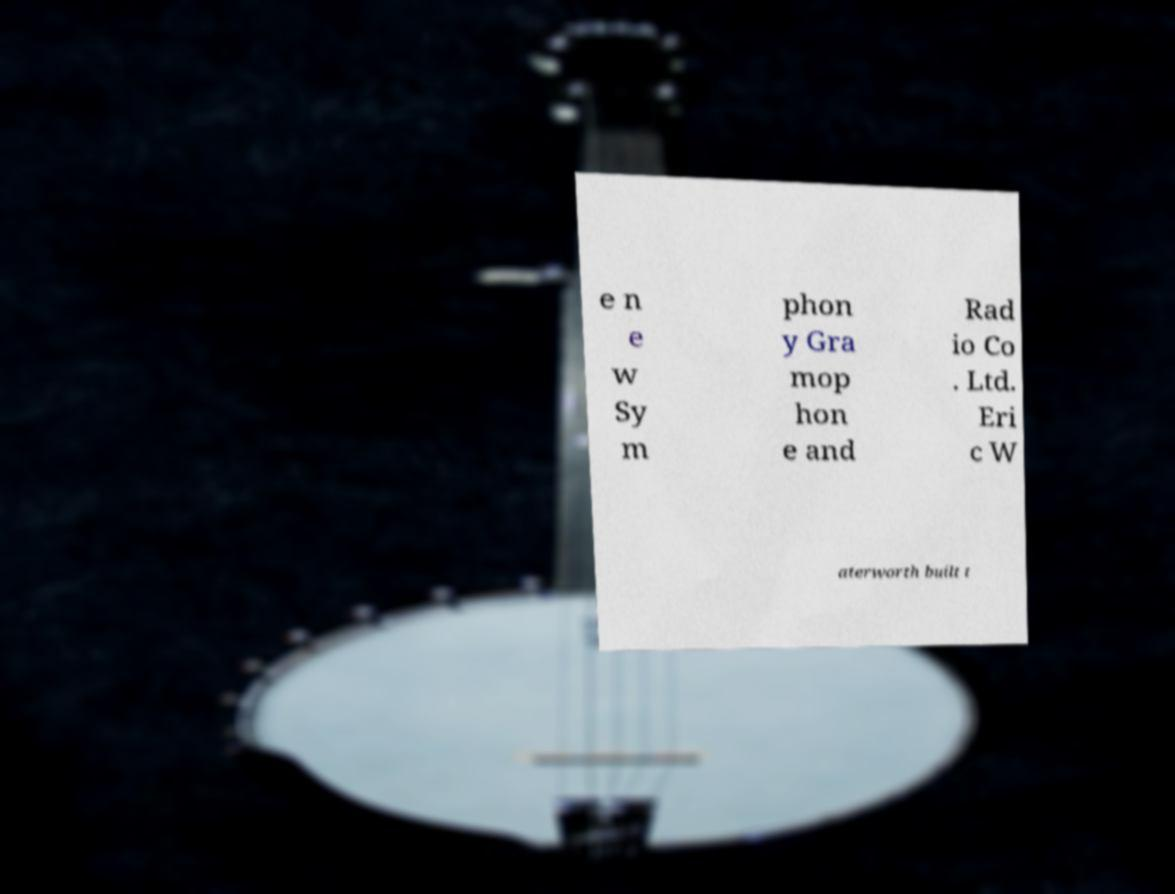Could you assist in decoding the text presented in this image and type it out clearly? e n e w Sy m phon y Gra mop hon e and Rad io Co . Ltd. Eri c W aterworth built t 